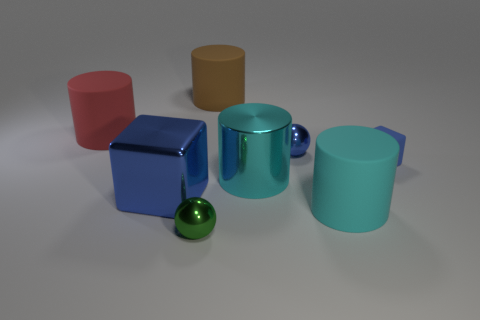What number of other things are there of the same material as the green sphere
Offer a very short reply. 3. What is the color of the ball that is on the right side of the metallic ball that is in front of the big rubber object that is in front of the small blue matte object?
Provide a succinct answer. Blue. What is the shape of the small metal object that is behind the rubber object in front of the big shiny cube?
Keep it short and to the point. Sphere. Are there more tiny metallic spheres to the right of the tiny green shiny thing than small brown matte spheres?
Your answer should be very brief. Yes. Do the cyan object that is left of the small blue shiny sphere and the tiny blue matte object have the same shape?
Make the answer very short. No. Is there a big brown object of the same shape as the large red rubber thing?
Ensure brevity in your answer.  Yes. How many things are metal cylinders left of the matte block or green balls?
Make the answer very short. 2. Are there more big red objects than big matte objects?
Your answer should be very brief. No. Is there a rubber thing of the same size as the green metallic object?
Give a very brief answer. Yes. How many things are either things in front of the brown thing or tiny metallic spheres that are to the left of the large brown cylinder?
Give a very brief answer. 7. 